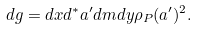<formula> <loc_0><loc_0><loc_500><loc_500>d g = d x d ^ { * } a ^ { \prime } d m d y \rho _ { P } ( a ^ { \prime } ) ^ { 2 } .</formula> 